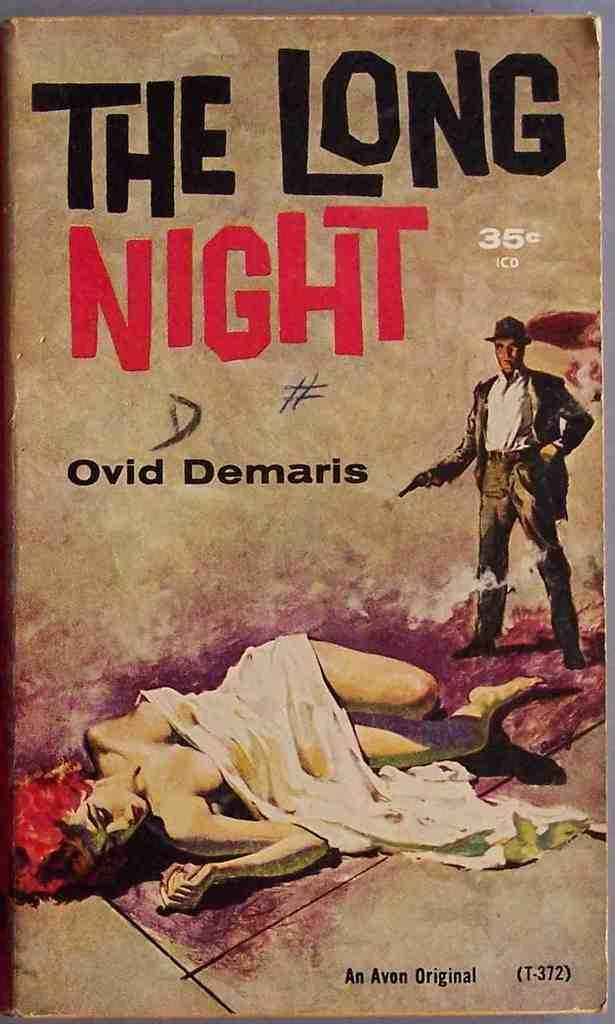<image>
Create a compact narrative representing the image presented. A book called The long night by Ovid Demaris 